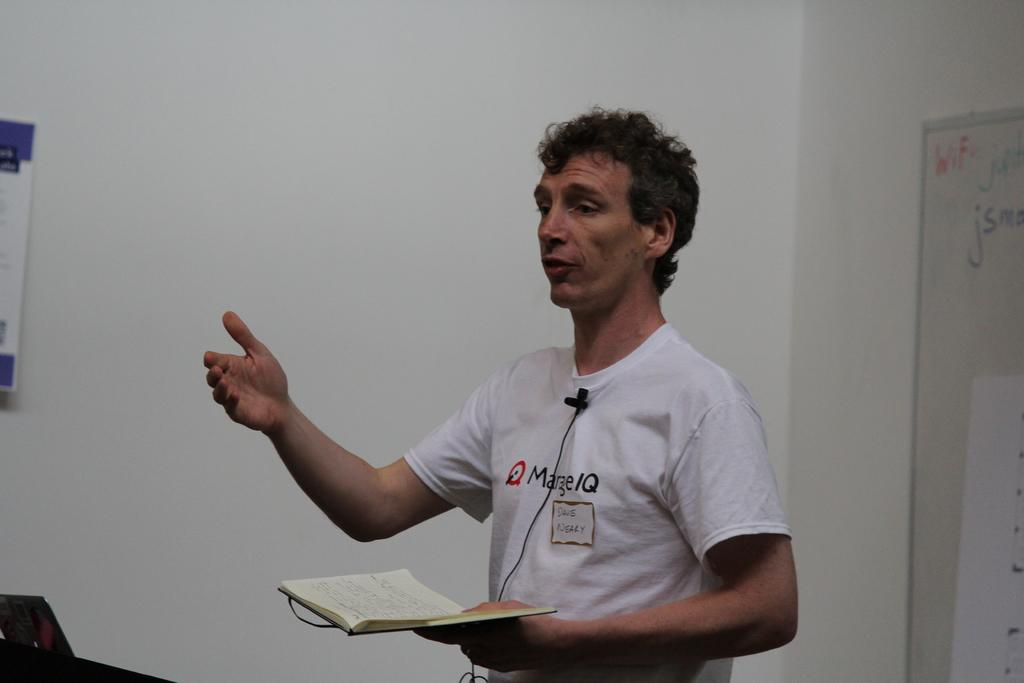<image>
Describe the image concisely. Man with a shirt saying Marge IQ giving a speech and holding a book. 